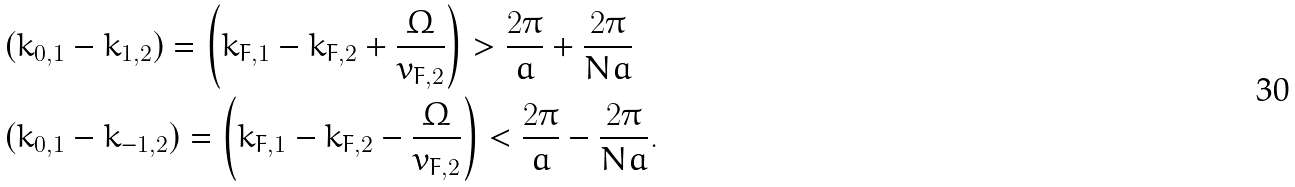Convert formula to latex. <formula><loc_0><loc_0><loc_500><loc_500>& ( k _ { 0 , 1 } - k _ { 1 , 2 } ) = \left ( k _ { F , 1 } - k _ { F , 2 } + \frac { \Omega } { v _ { F , 2 } } \right ) > \frac { 2 \pi } { a } + \frac { 2 \pi } { N a } \\ & ( k _ { 0 , 1 } - k _ { - 1 , 2 } ) = \left ( k _ { F , 1 } - k _ { F , 2 } - \frac { \Omega } { v _ { F , 2 } } \right ) < \frac { 2 \pi } { a } - \frac { 2 \pi } { N a } .</formula> 